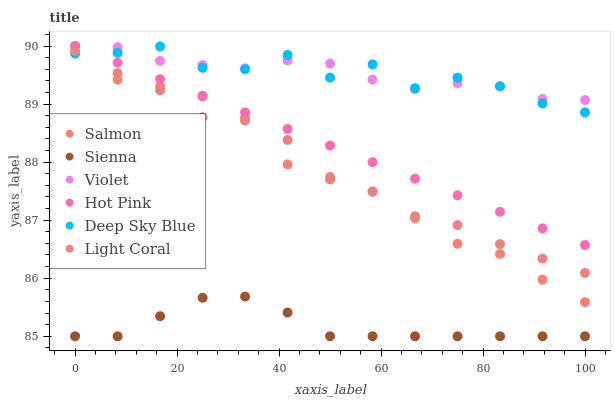Does Sienna have the minimum area under the curve?
Answer yes or no. Yes. Does Deep Sky Blue have the maximum area under the curve?
Answer yes or no. Yes. Does Hot Pink have the minimum area under the curve?
Answer yes or no. No. Does Hot Pink have the maximum area under the curve?
Answer yes or no. No. Is Hot Pink the smoothest?
Answer yes or no. Yes. Is Deep Sky Blue the roughest?
Answer yes or no. Yes. Is Salmon the smoothest?
Answer yes or no. No. Is Salmon the roughest?
Answer yes or no. No. Does Sienna have the lowest value?
Answer yes or no. Yes. Does Hot Pink have the lowest value?
Answer yes or no. No. Does Violet have the highest value?
Answer yes or no. Yes. Does Sienna have the highest value?
Answer yes or no. No. Is Sienna less than Light Coral?
Answer yes or no. Yes. Is Violet greater than Light Coral?
Answer yes or no. Yes. Does Salmon intersect Light Coral?
Answer yes or no. Yes. Is Salmon less than Light Coral?
Answer yes or no. No. Is Salmon greater than Light Coral?
Answer yes or no. No. Does Sienna intersect Light Coral?
Answer yes or no. No. 